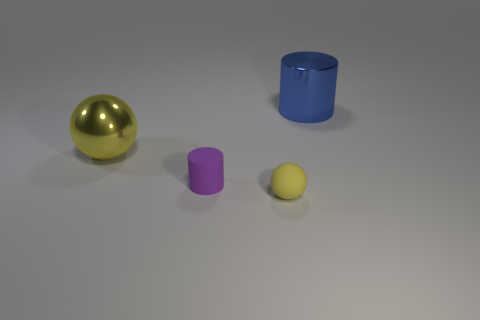There is a purple matte object; how many purple things are in front of it?
Provide a short and direct response. 0. How big is the purple rubber thing?
Offer a very short reply. Small. Does the purple thing left of the blue metal object have the same material as the big thing that is to the right of the small sphere?
Give a very brief answer. No. Is there a large object of the same color as the metallic cylinder?
Make the answer very short. No. There is another object that is the same size as the purple thing; what color is it?
Your answer should be compact. Yellow. Is the color of the large metallic object that is left of the tiny cylinder the same as the small sphere?
Provide a succinct answer. Yes. Is there a big purple object that has the same material as the big cylinder?
Offer a terse response. No. There is a small thing that is the same color as the large shiny sphere; what shape is it?
Offer a terse response. Sphere. Are there fewer small purple rubber cylinders that are in front of the yellow matte thing than large balls?
Provide a succinct answer. Yes. Do the ball behind the purple rubber cylinder and the blue thing have the same size?
Ensure brevity in your answer.  Yes. 